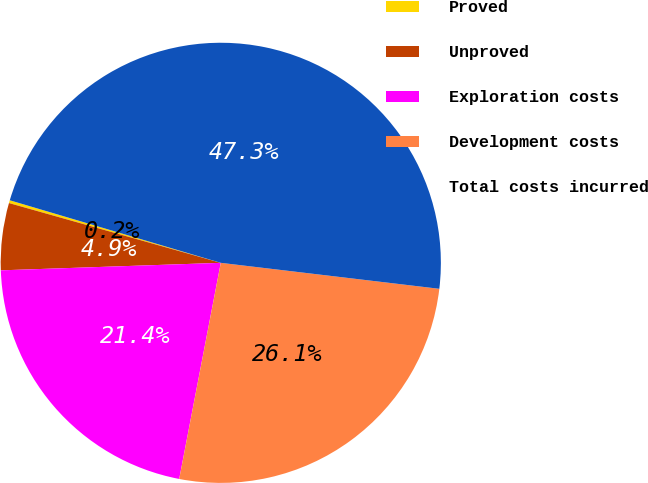Convert chart to OTSL. <chart><loc_0><loc_0><loc_500><loc_500><pie_chart><fcel>Proved<fcel>Unproved<fcel>Exploration costs<fcel>Development costs<fcel>Total costs incurred<nl><fcel>0.21%<fcel>4.92%<fcel>21.43%<fcel>26.14%<fcel>47.29%<nl></chart> 